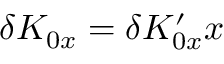Convert formula to latex. <formula><loc_0><loc_0><loc_500><loc_500>\delta K _ { 0 x } = \delta K _ { 0 x } ^ { \prime } x</formula> 